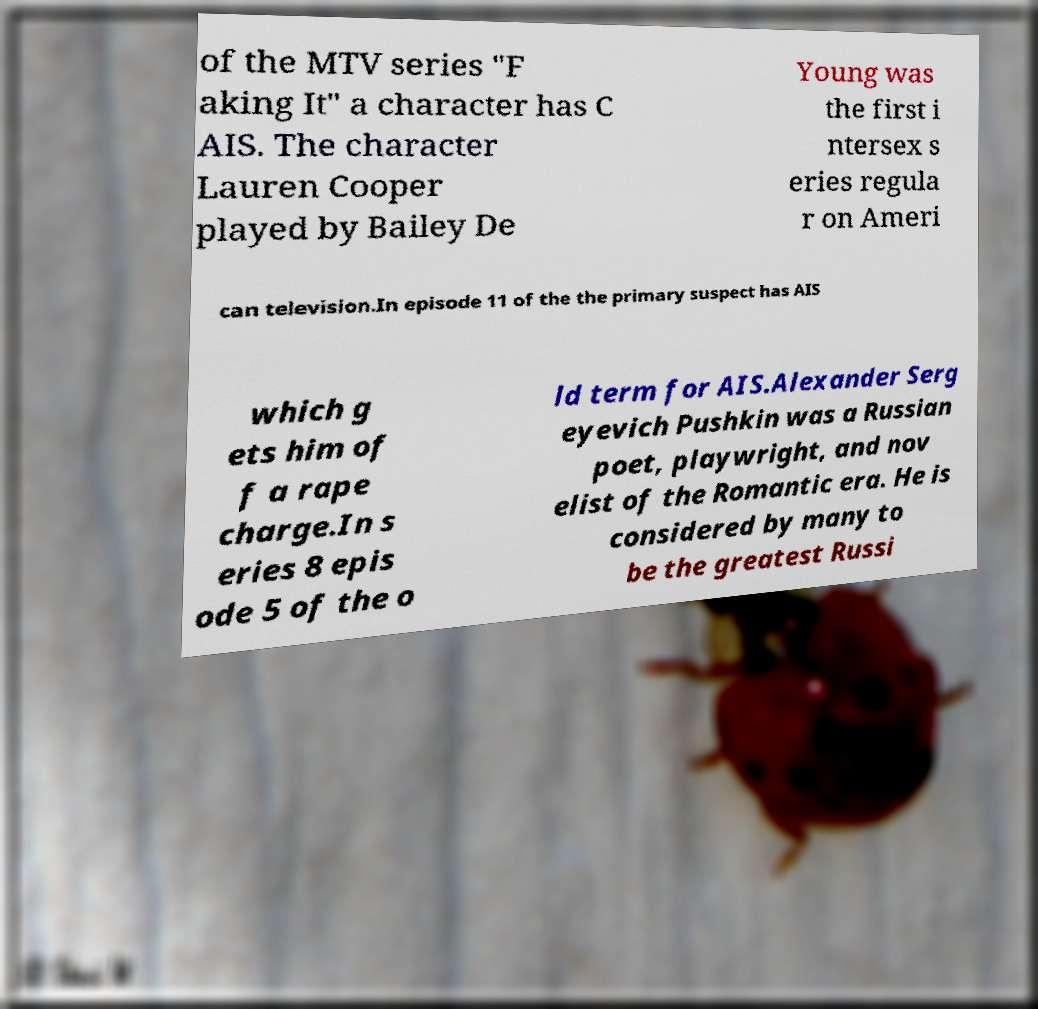Can you accurately transcribe the text from the provided image for me? of the MTV series "F aking It" a character has C AIS. The character Lauren Cooper played by Bailey De Young was the first i ntersex s eries regula r on Ameri can television.In episode 11 of the the primary suspect has AIS which g ets him of f a rape charge.In s eries 8 epis ode 5 of the o ld term for AIS.Alexander Serg eyevich Pushkin was a Russian poet, playwright, and nov elist of the Romantic era. He is considered by many to be the greatest Russi 